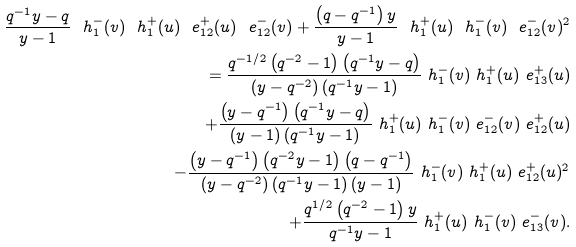<formula> <loc_0><loc_0><loc_500><loc_500>\frac { q ^ { - 1 } y - q } { y - 1 } \ h _ { 1 } ^ { - } ( v ) \ h _ { 1 } ^ { + } ( u ) \ e _ { 1 2 } ^ { + } ( u ) \ e _ { 1 2 } ^ { - } ( v ) + \frac { \left ( q - q ^ { - 1 } \right ) y } { y - 1 } \ h _ { 1 } ^ { + } ( u ) \ h _ { 1 } ^ { - } ( v ) \ e _ { 1 2 } ^ { - } ( v ) ^ { 2 } \\ = \frac { q ^ { - 1 / 2 } \left ( q ^ { - 2 } - 1 \right ) \left ( q ^ { - 1 } y - q \right ) } { \left ( y - q ^ { - 2 } \right ) \left ( q ^ { - 1 } y - 1 \right ) } \ h _ { 1 } ^ { - } ( v ) \ h _ { 1 } ^ { + } ( u ) \ e _ { 1 3 } ^ { + } ( u ) \\ \quad + \frac { \left ( y - q ^ { - 1 } \right ) \left ( q ^ { - 1 } y - q \right ) } { ( y - 1 ) \left ( q ^ { - 1 } y - 1 \right ) } \ h _ { 1 } ^ { + } ( u ) \ h _ { 1 } ^ { - } ( v ) \ e _ { 1 2 } ^ { - } ( v ) \ e _ { 1 2 } ^ { + } ( u ) \\ \quad - \frac { \left ( y - q ^ { - 1 } \right ) \left ( q ^ { - 2 } y - 1 \right ) \left ( q - q ^ { - 1 } \right ) } { \left ( y - q ^ { - 2 } \right ) \left ( q ^ { - 1 } y - 1 \right ) ( y - 1 ) } \ h _ { 1 } ^ { - } ( v ) \ h _ { 1 } ^ { + } ( u ) \ e _ { 1 2 } ^ { + } ( u ) ^ { 2 } \\ \quad + \frac { q ^ { 1 / 2 } \left ( q ^ { - 2 } - 1 \right ) y } { q ^ { - 1 } y - 1 } \ h _ { 1 } ^ { + } ( u ) \ h _ { 1 } ^ { - } ( v ) \ e _ { 1 3 } ^ { - } ( v ) .</formula> 